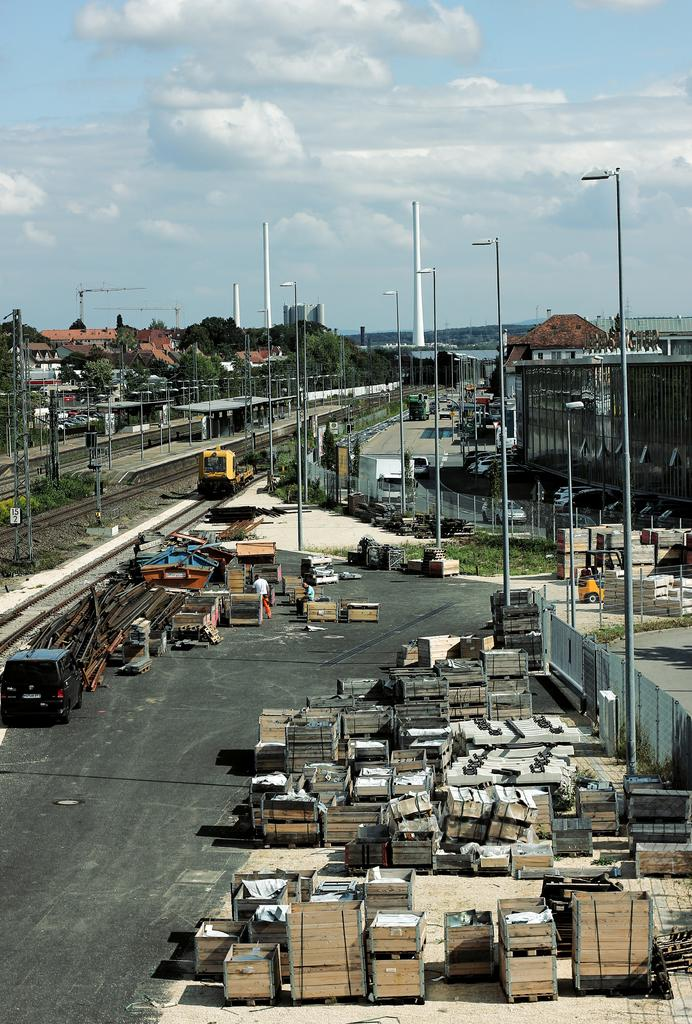What type of structures can be seen in the image? There are buildings in the image. What mode of transportation is present in the image? There is a train on the track in the image. What is on the road in the image? There are objects on the road in the image. What type of vegetation is in the image? There are trees in the image. What are the tall, thin structures in the image? There are poles in the image. What can be seen in the background of the image? The sky is visible in the image. Where is the parent taking a bath with the tub in the image? There is no tub or parent present in the image. How does the train smash through the buildings in the image? The train does not smash through the buildings in the image; it is on the track, and the buildings are separate structures. 